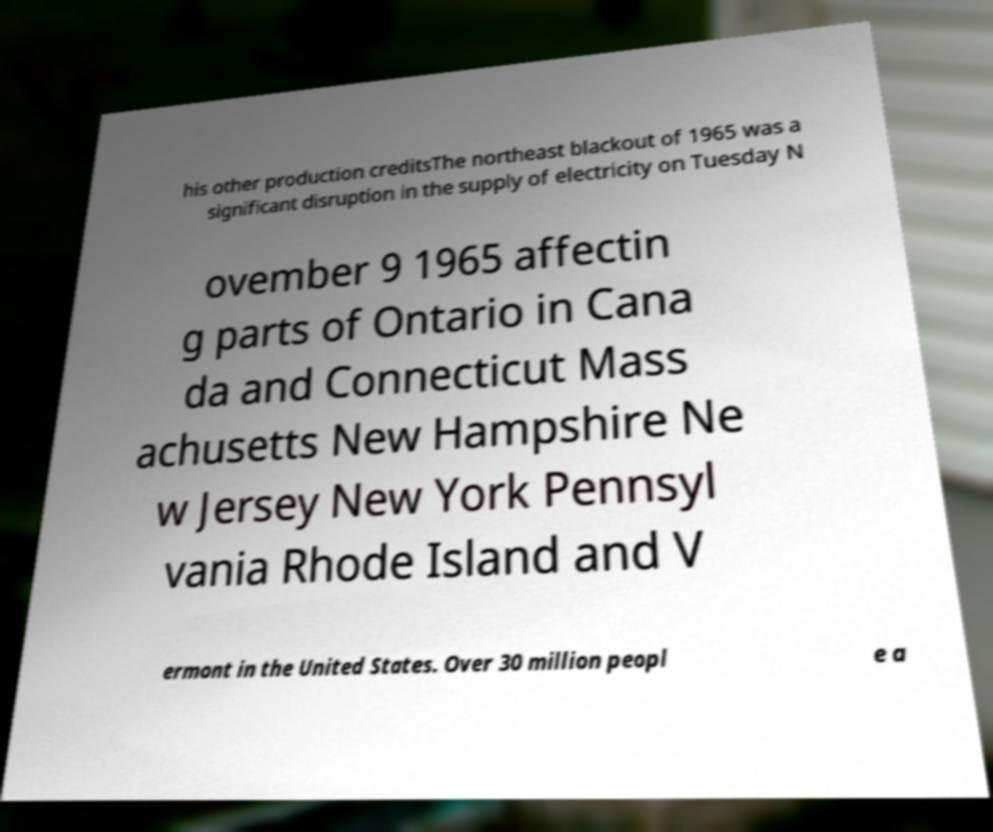There's text embedded in this image that I need extracted. Can you transcribe it verbatim? his other production creditsThe northeast blackout of 1965 was a significant disruption in the supply of electricity on Tuesday N ovember 9 1965 affectin g parts of Ontario in Cana da and Connecticut Mass achusetts New Hampshire Ne w Jersey New York Pennsyl vania Rhode Island and V ermont in the United States. Over 30 million peopl e a 